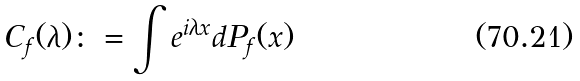Convert formula to latex. <formula><loc_0><loc_0><loc_500><loc_500>C _ { f } ( \lambda ) \colon = \int e ^ { i \lambda x } d P _ { f } ( x )</formula> 